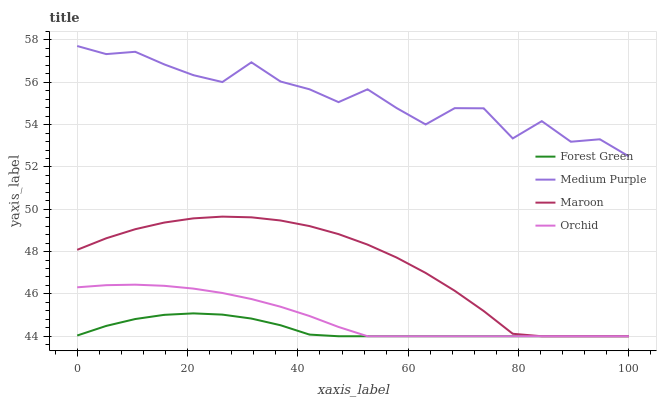Does Forest Green have the minimum area under the curve?
Answer yes or no. Yes. Does Medium Purple have the maximum area under the curve?
Answer yes or no. Yes. Does Maroon have the minimum area under the curve?
Answer yes or no. No. Does Maroon have the maximum area under the curve?
Answer yes or no. No. Is Orchid the smoothest?
Answer yes or no. Yes. Is Medium Purple the roughest?
Answer yes or no. Yes. Is Forest Green the smoothest?
Answer yes or no. No. Is Forest Green the roughest?
Answer yes or no. No. Does Forest Green have the lowest value?
Answer yes or no. Yes. Does Medium Purple have the highest value?
Answer yes or no. Yes. Does Maroon have the highest value?
Answer yes or no. No. Is Forest Green less than Medium Purple?
Answer yes or no. Yes. Is Medium Purple greater than Maroon?
Answer yes or no. Yes. Does Orchid intersect Forest Green?
Answer yes or no. Yes. Is Orchid less than Forest Green?
Answer yes or no. No. Is Orchid greater than Forest Green?
Answer yes or no. No. Does Forest Green intersect Medium Purple?
Answer yes or no. No. 